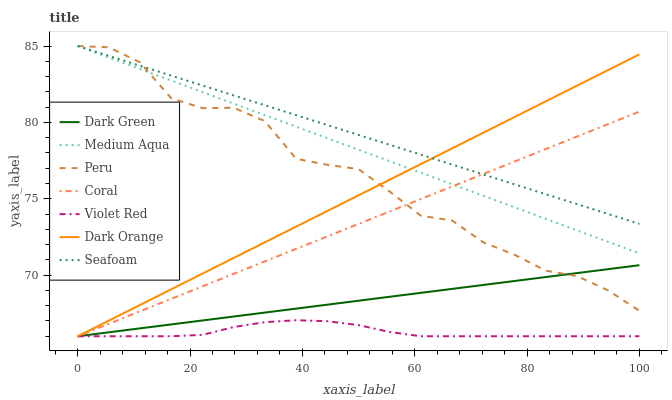Does Violet Red have the minimum area under the curve?
Answer yes or no. Yes. Does Seafoam have the maximum area under the curve?
Answer yes or no. Yes. Does Coral have the minimum area under the curve?
Answer yes or no. No. Does Coral have the maximum area under the curve?
Answer yes or no. No. Is Coral the smoothest?
Answer yes or no. Yes. Is Peru the roughest?
Answer yes or no. Yes. Is Violet Red the smoothest?
Answer yes or no. No. Is Violet Red the roughest?
Answer yes or no. No. Does Seafoam have the lowest value?
Answer yes or no. No. Does Peru have the highest value?
Answer yes or no. Yes. Does Coral have the highest value?
Answer yes or no. No. Is Dark Green less than Medium Aqua?
Answer yes or no. Yes. Is Seafoam greater than Violet Red?
Answer yes or no. Yes. Does Dark Green intersect Medium Aqua?
Answer yes or no. No. 